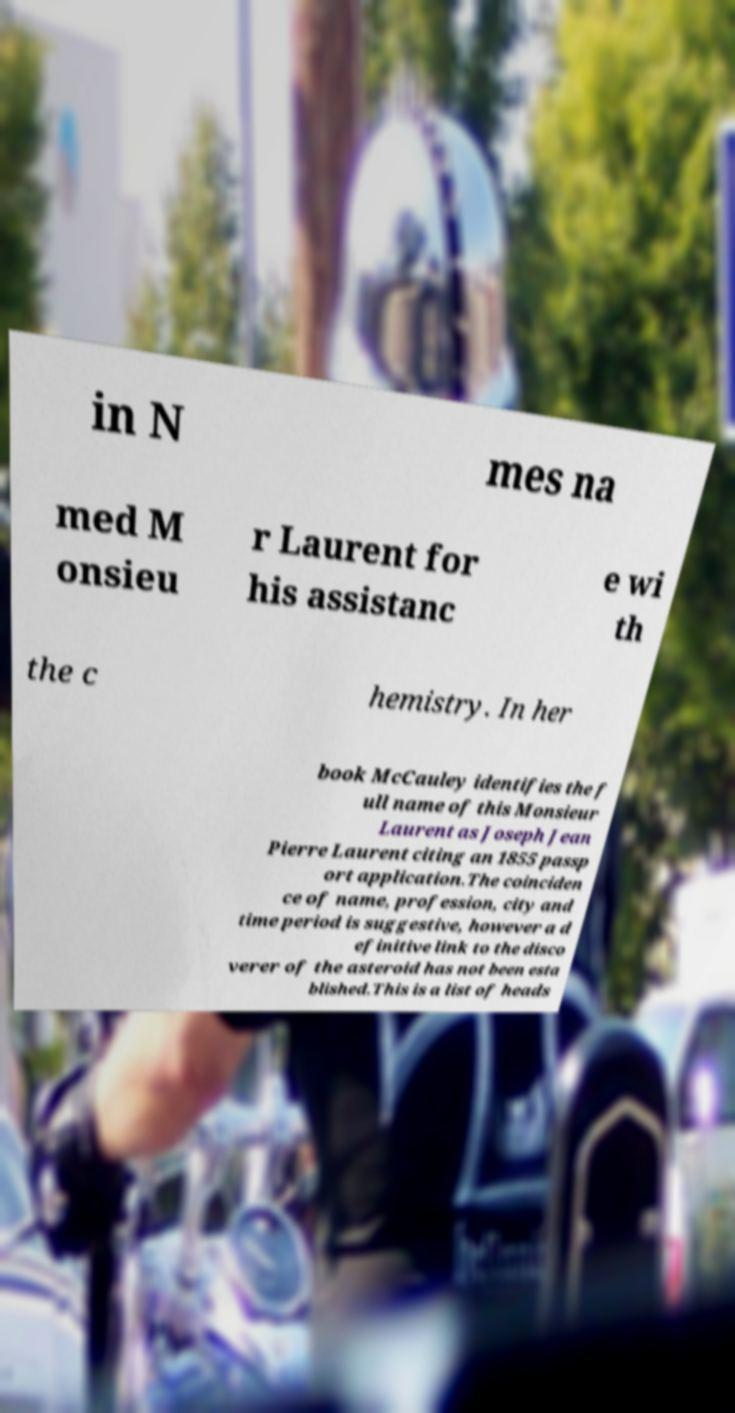There's text embedded in this image that I need extracted. Can you transcribe it verbatim? in N mes na med M onsieu r Laurent for his assistanc e wi th the c hemistry. In her book McCauley identifies the f ull name of this Monsieur Laurent as Joseph Jean Pierre Laurent citing an 1855 passp ort application.The coinciden ce of name, profession, city and time period is suggestive, however a d efinitive link to the disco verer of the asteroid has not been esta blished.This is a list of heads 